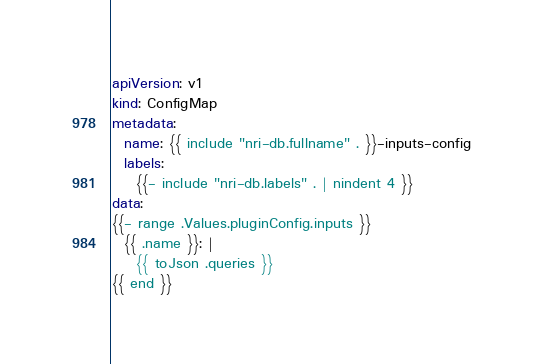Convert code to text. <code><loc_0><loc_0><loc_500><loc_500><_YAML_>apiVersion: v1
kind: ConfigMap
metadata:
  name: {{ include "nri-db.fullname" . }}-inputs-config
  labels:
    {{- include "nri-db.labels" . | nindent 4 }}
data:
{{- range .Values.pluginConfig.inputs }}
  {{ .name }}: |
    {{ toJson .queries }}
{{ end }}
</code> 